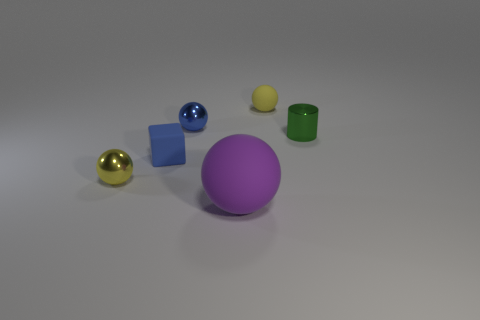What material is the tiny blue thing that is behind the thing on the right side of the tiny yellow sphere behind the small yellow shiny thing?
Keep it short and to the point. Metal. What number of tiny balls are behind the yellow thing that is to the left of the small blue shiny ball?
Offer a very short reply. 2. There is a large matte object that is the same shape as the tiny yellow rubber thing; what color is it?
Your response must be concise. Purple. Does the blue ball have the same material as the purple ball?
Your response must be concise. No. What number of cylinders are green shiny things or large objects?
Your answer should be compact. 1. There is a metal sphere behind the shiny thing that is right of the yellow ball behind the blue sphere; how big is it?
Provide a succinct answer. Small. The other metallic thing that is the same shape as the blue metal object is what size?
Keep it short and to the point. Small. There is a purple rubber ball; how many yellow metallic spheres are in front of it?
Ensure brevity in your answer.  0. Does the tiny metallic ball that is behind the small blue rubber cube have the same color as the small rubber ball?
Provide a short and direct response. No. What number of gray objects are either matte balls or big things?
Give a very brief answer. 0. 